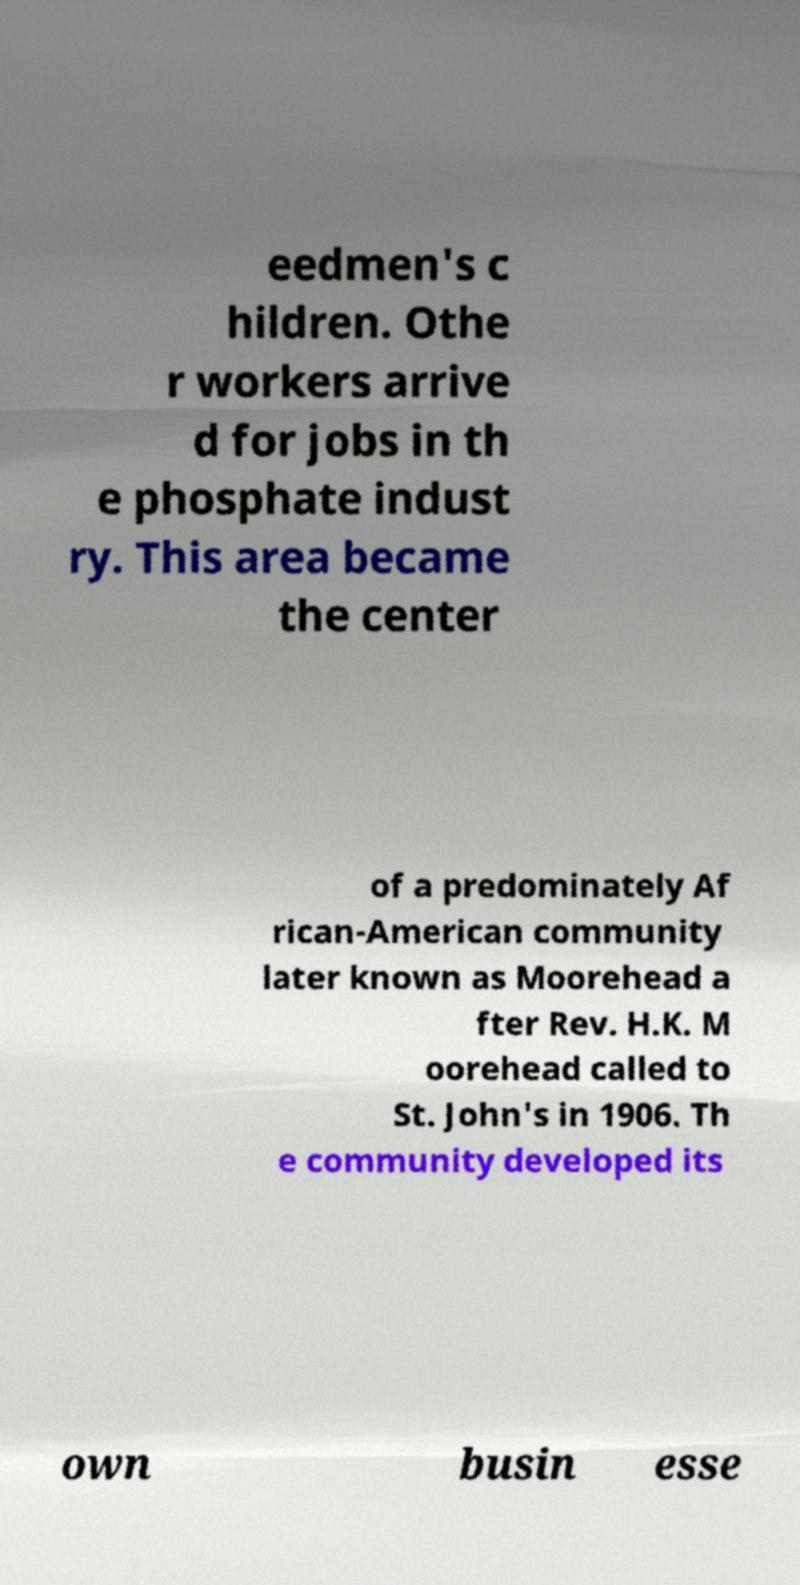Could you extract and type out the text from this image? eedmen's c hildren. Othe r workers arrive d for jobs in th e phosphate indust ry. This area became the center of a predominately Af rican-American community later known as Moorehead a fter Rev. H.K. M oorehead called to St. John's in 1906. Th e community developed its own busin esse 